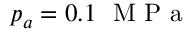<formula> <loc_0><loc_0><loc_500><loc_500>p _ { a } = 0 . 1 M P a</formula> 